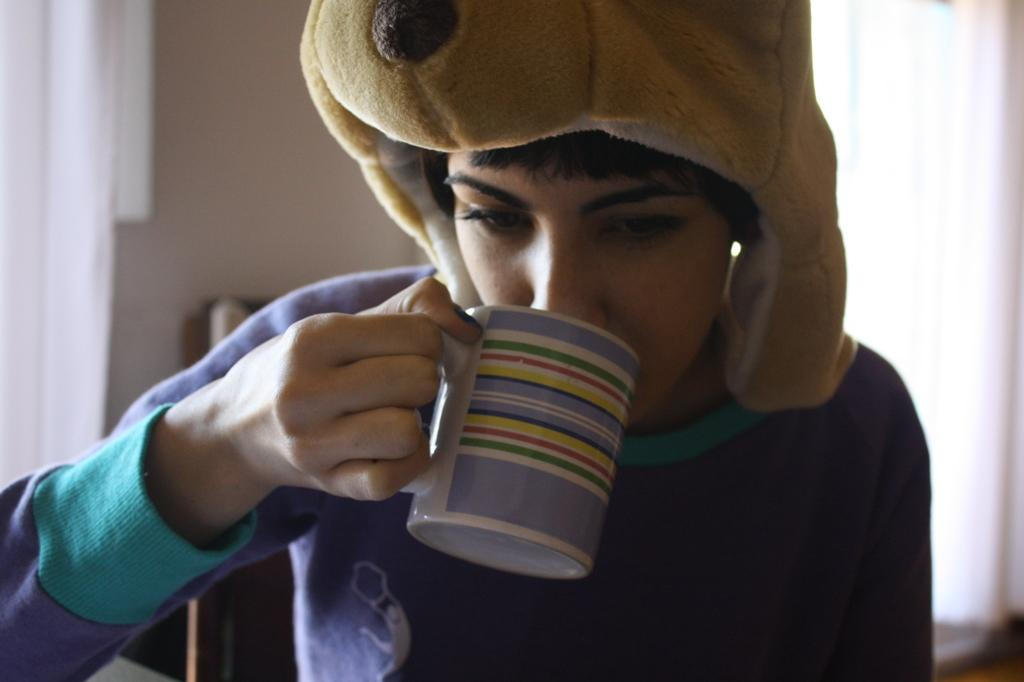What is the person in the image doing? The person is sitting in the image. What is the person holding in the image? The person is holding a cup. What can be seen behind the person in the image? There is a wall visible behind the person. Is there any window treatment associated with the wall? Yes, there is a curtain associated with the wall. What type of ant can be seen crawling on the cup in the image? There are no ants present in the image, and therefore no such activity can be observed. 